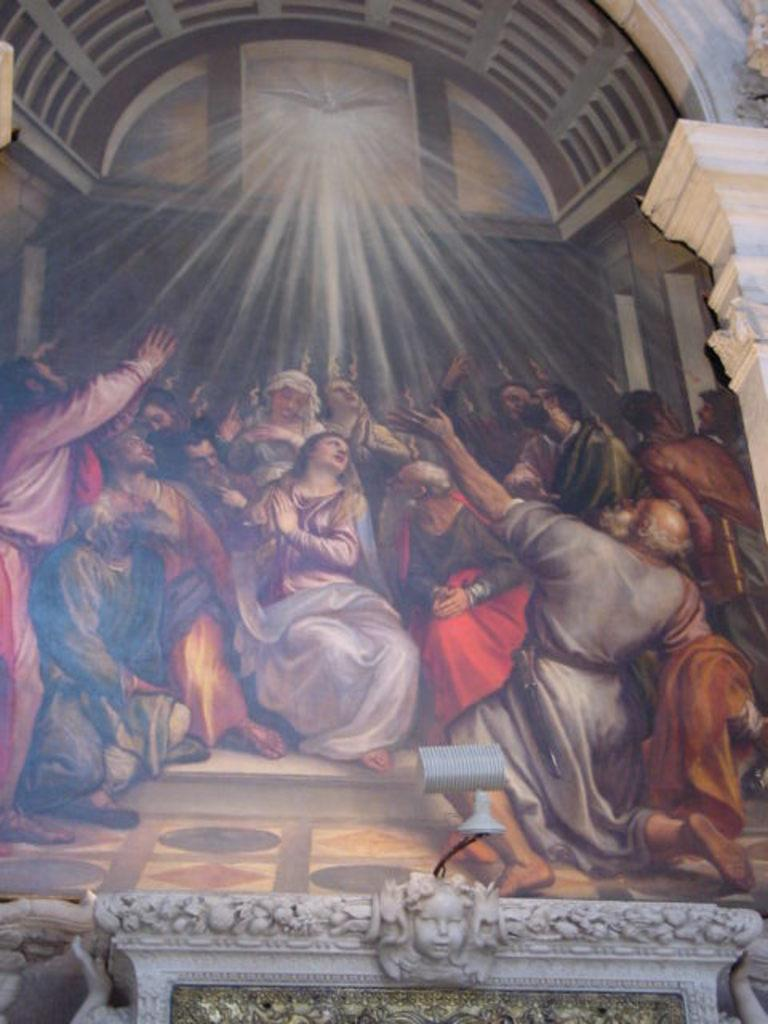What is depicted on the object in the image? There is a sculpture on an object in the image. What type of artwork is present in the image besides the sculpture? There is a painting of a few people and a painting of a bird in the image. What else can be seen in the painting? There are other things depicted in the painting. What architectural features are present in the image? There is an arch and a pillar in the image. How far away is the linen from the sculpture in the image? There is no linen present in the image, so it cannot be determined how far away it might be from the sculpture. Can you tell me how many times the bird jumps in the painting? The painting does not depict the bird jumping; it is simply a painting of a bird. 